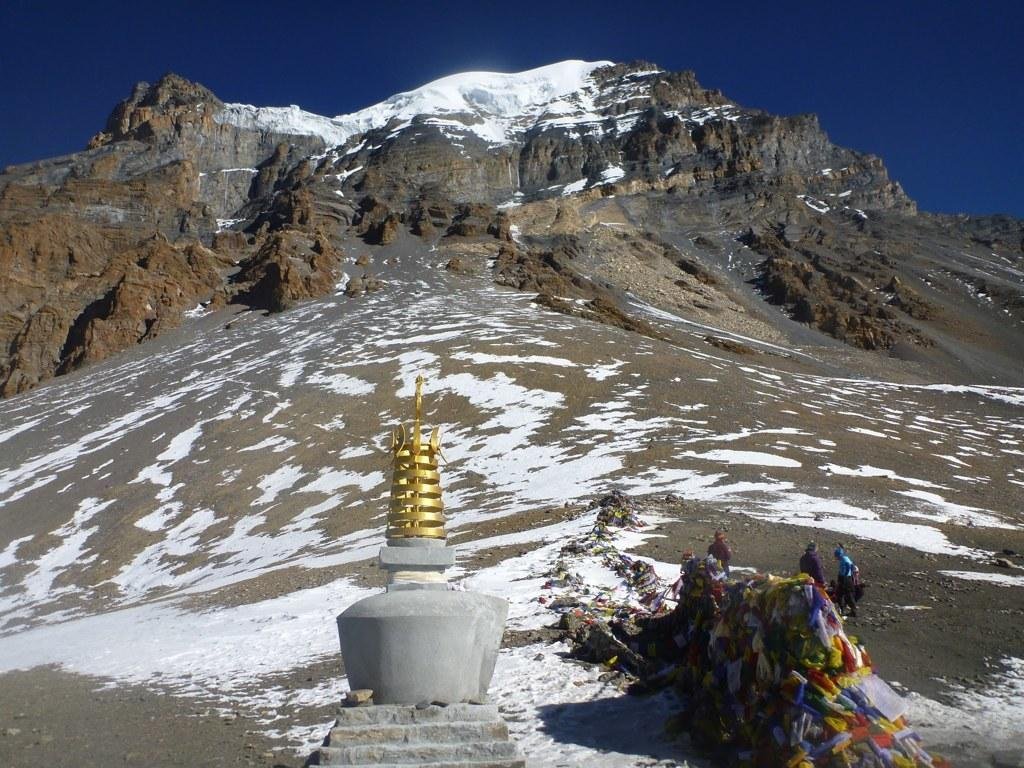What is the primary feature of the landscape in the image? There is snow in the image. What are the people in the image doing? The people are standing on the ground in the image. What geographical feature can be seen in the image? There is a mountain in the image. What else can be seen in the image besides the snow, people, and mountain? There are other objects in the image. What is visible in the background of the image? The sky is visible in the background of the image. What type of thread is being used to sew the toes of the people in the image? There is no indication in the image that the people's toes are being sewn or that thread is involved. What type of juice can be seen being consumed by the people in the image? There is no juice visible in the image; the people are standing on the ground, and there is no mention of any food or drink. 